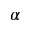<formula> <loc_0><loc_0><loc_500><loc_500>\alpha</formula> 